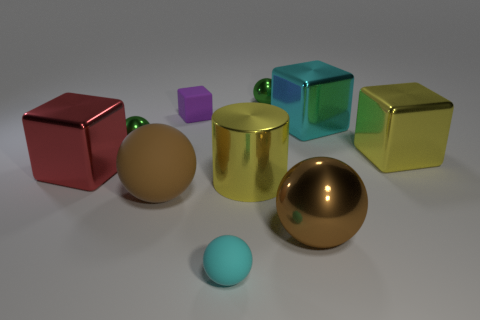What might be the practical applications of creating such a 3D rendered image? Creating a 3D rendered image like this can have several practical applications, including product visualization, graphic design, and educational purposes. It serves as a way to showcase rendering techniques, such as reflections, textures, and lighting in a controlled environment. 